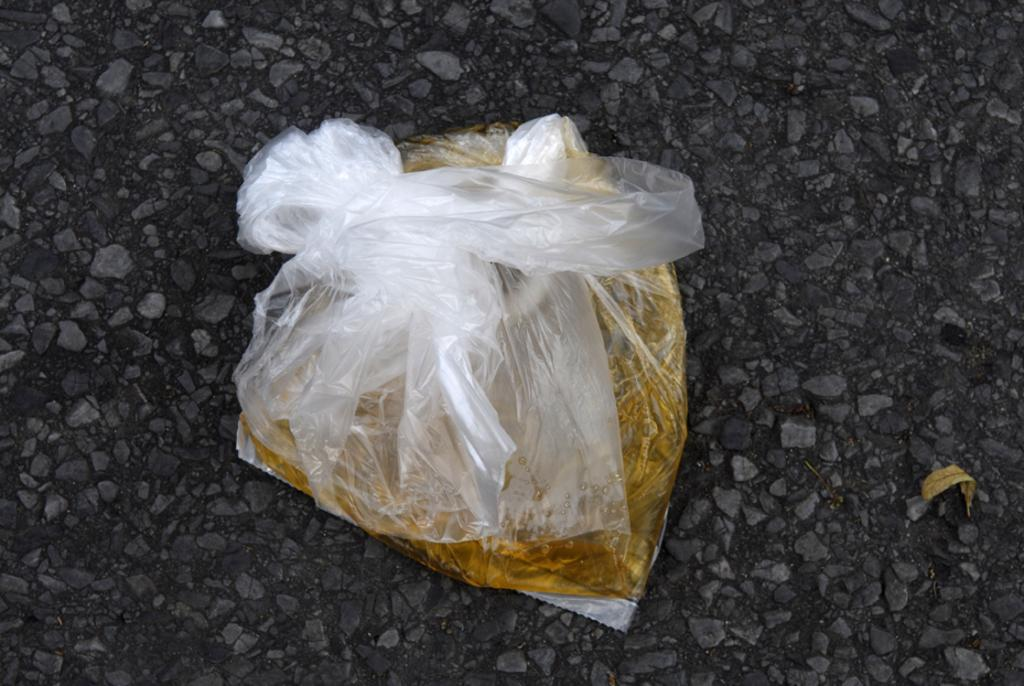What is the main object in the image? There is a transparent polythene cover in the image. What is inside the polythene cover? The polythene cover contains a golden color liquid. Where is the polythene cover located? The polythene cover is on the road. What other object can be seen in the image? There is a dry leaf in the image. What type of veil is the daughter wearing in the image? There is no daughter or veil present in the image. Can you see the ocean in the background of the image? There is no ocean visible in the image; it features a polythene cover with a golden liquid on the road and a dry leaf. 